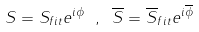<formula> <loc_0><loc_0><loc_500><loc_500>S = S _ { f i t } e ^ { i \phi } \ , \ \overline { S } = \overline { S } _ { f i t } e ^ { i \overline { \phi } }</formula> 